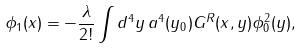<formula> <loc_0><loc_0><loc_500><loc_500>\phi _ { 1 } ( x ) = - \frac { \lambda } { 2 ! } \int d ^ { 4 } y \, a ^ { 4 } ( y _ { 0 } ) G ^ { R } ( x , y ) \phi _ { 0 } ^ { 2 } ( y ) ,</formula> 